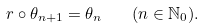<formula> <loc_0><loc_0><loc_500><loc_500>r \circ \theta _ { n + 1 } = \theta _ { n } \quad ( n \in \mathbb { N } _ { 0 } ) .</formula> 